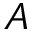Convert formula to latex. <formula><loc_0><loc_0><loc_500><loc_500>A</formula> 